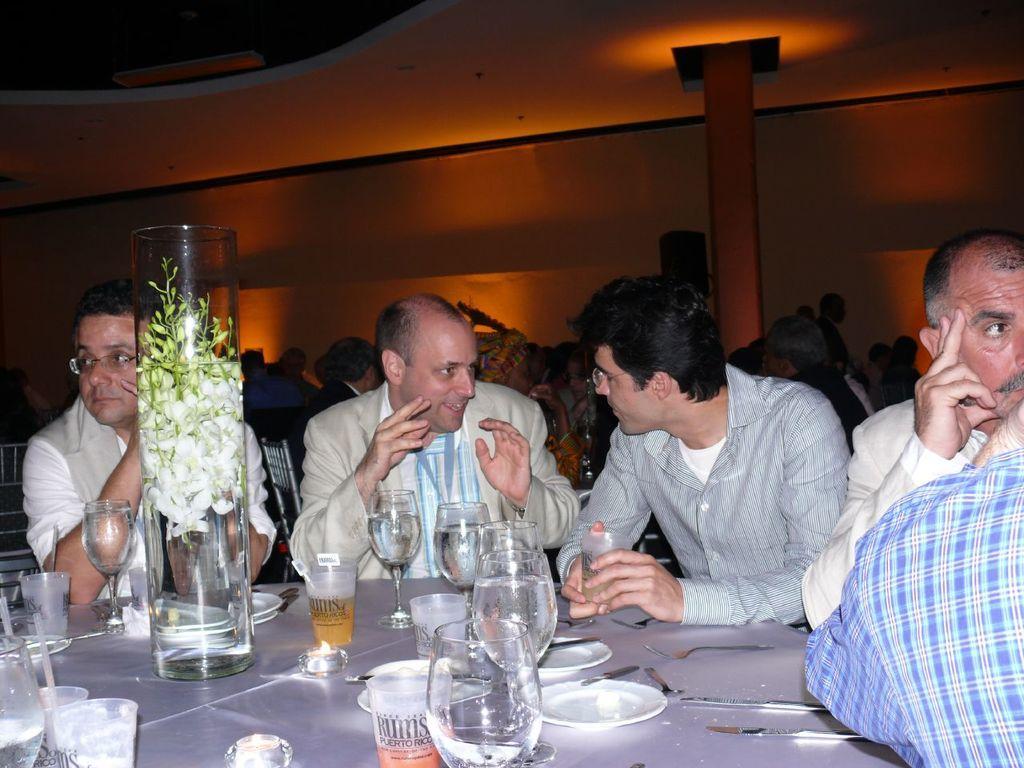Could you give a brief overview of what you see in this image? In this image we can see people sitting near the table. We can see glasses, plates, forks, knife and flower vase on the table. In the background we can see people and wall. 